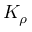Convert formula to latex. <formula><loc_0><loc_0><loc_500><loc_500>K _ { \rho }</formula> 